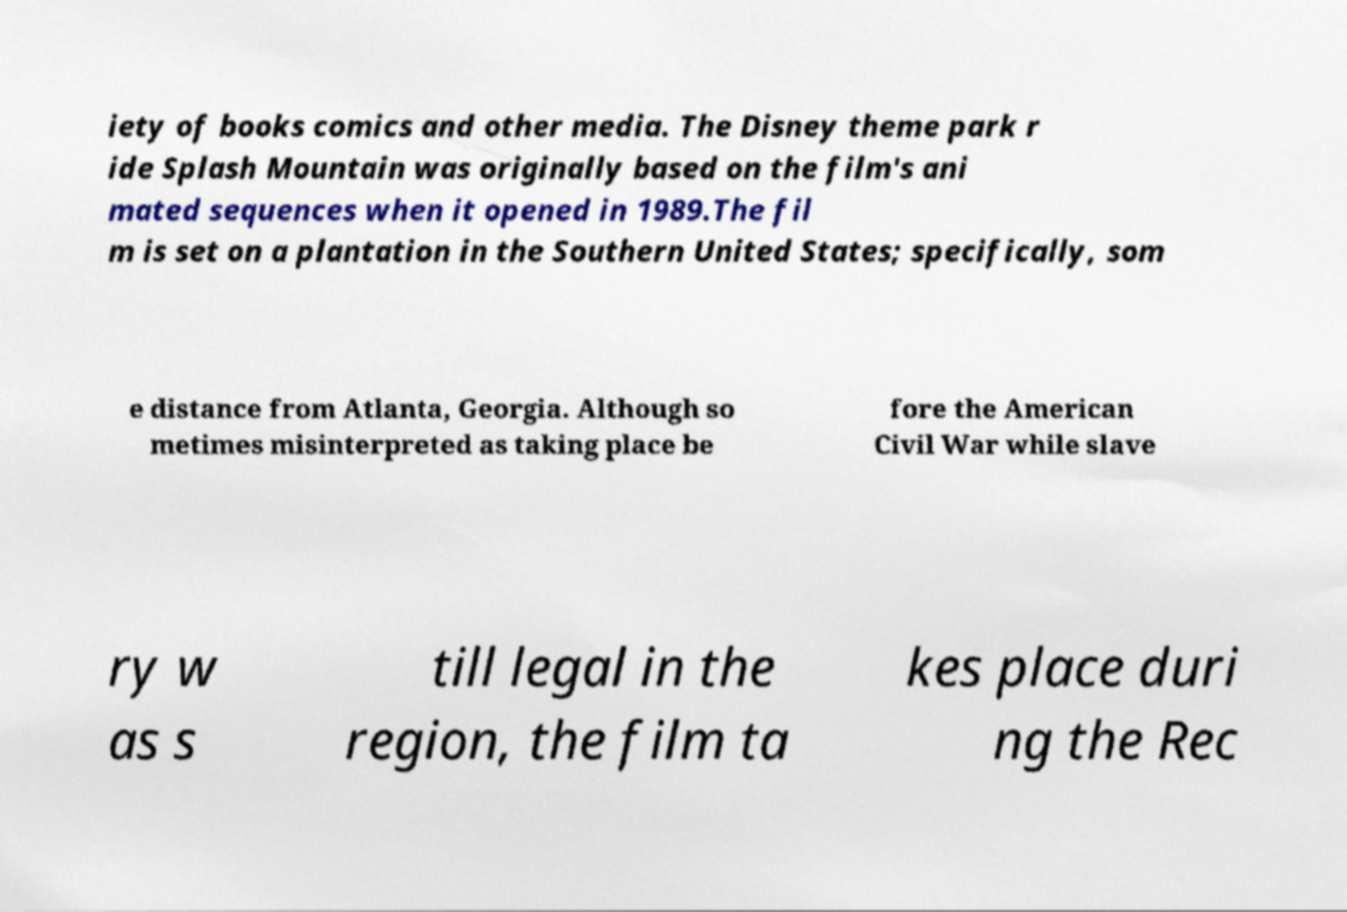Could you assist in decoding the text presented in this image and type it out clearly? iety of books comics and other media. The Disney theme park r ide Splash Mountain was originally based on the film's ani mated sequences when it opened in 1989.The fil m is set on a plantation in the Southern United States; specifically, som e distance from Atlanta, Georgia. Although so metimes misinterpreted as taking place be fore the American Civil War while slave ry w as s till legal in the region, the film ta kes place duri ng the Rec 